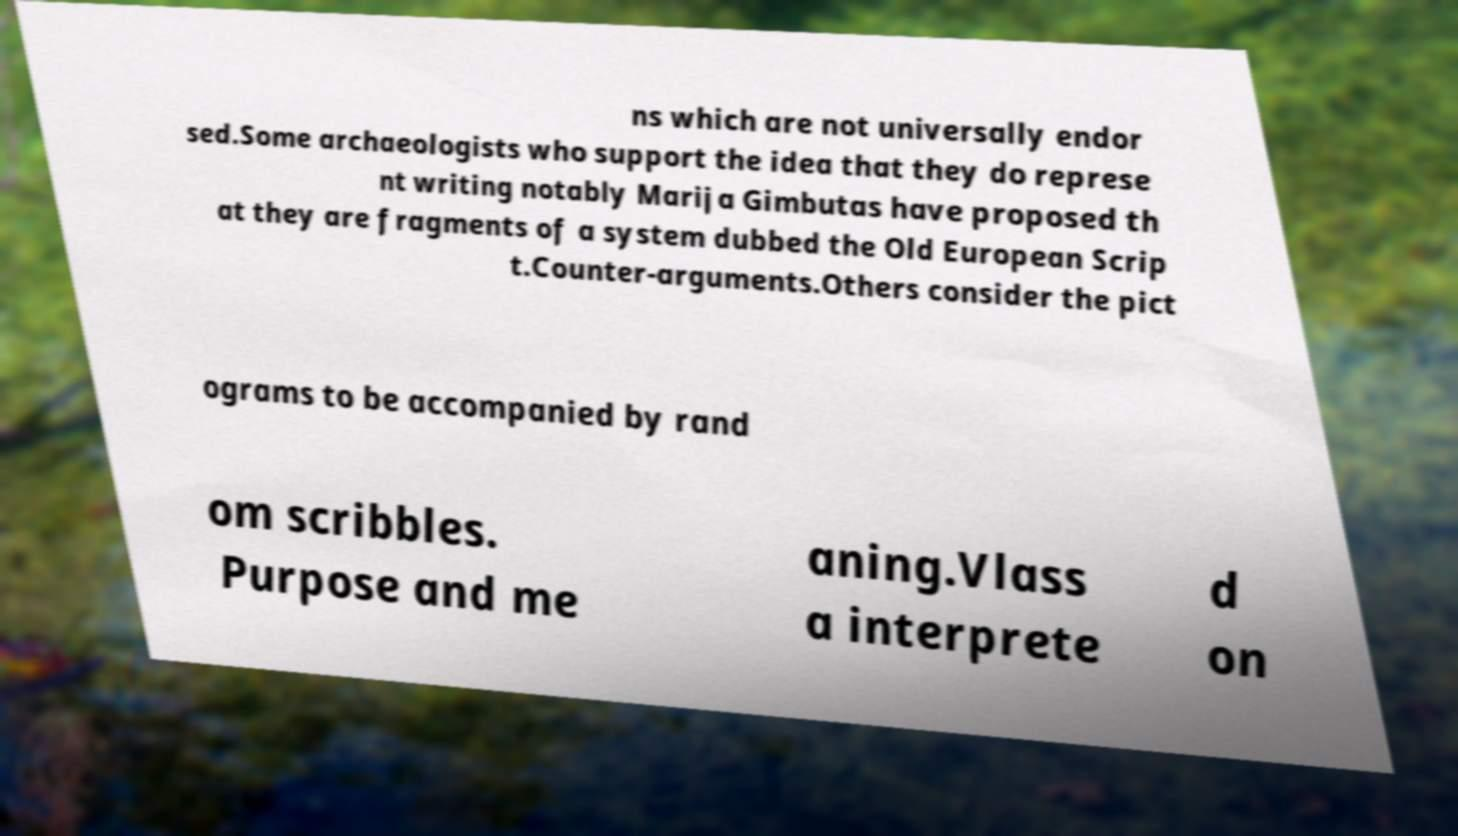Could you extract and type out the text from this image? ns which are not universally endor sed.Some archaeologists who support the idea that they do represe nt writing notably Marija Gimbutas have proposed th at they are fragments of a system dubbed the Old European Scrip t.Counter-arguments.Others consider the pict ograms to be accompanied by rand om scribbles. Purpose and me aning.Vlass a interprete d on 